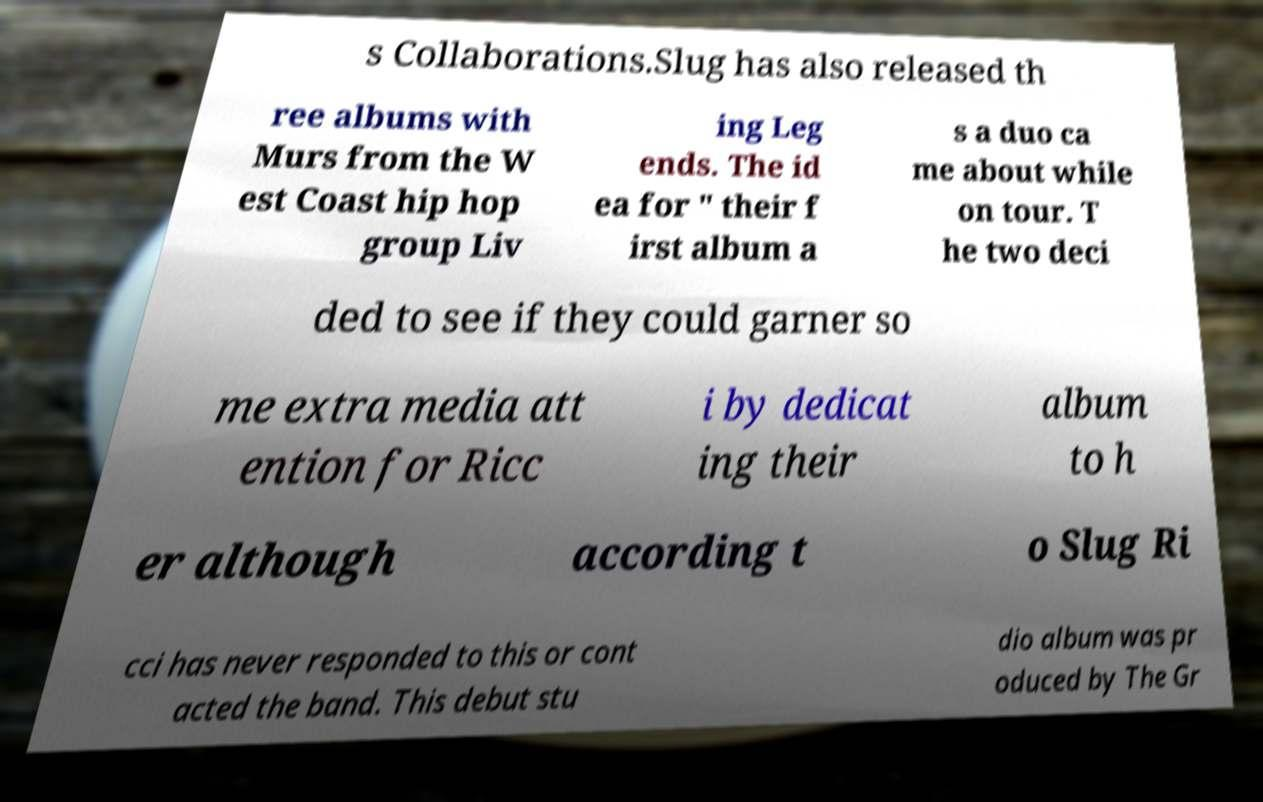Could you assist in decoding the text presented in this image and type it out clearly? s Collaborations.Slug has also released th ree albums with Murs from the W est Coast hip hop group Liv ing Leg ends. The id ea for " their f irst album a s a duo ca me about while on tour. T he two deci ded to see if they could garner so me extra media att ention for Ricc i by dedicat ing their album to h er although according t o Slug Ri cci has never responded to this or cont acted the band. This debut stu dio album was pr oduced by The Gr 